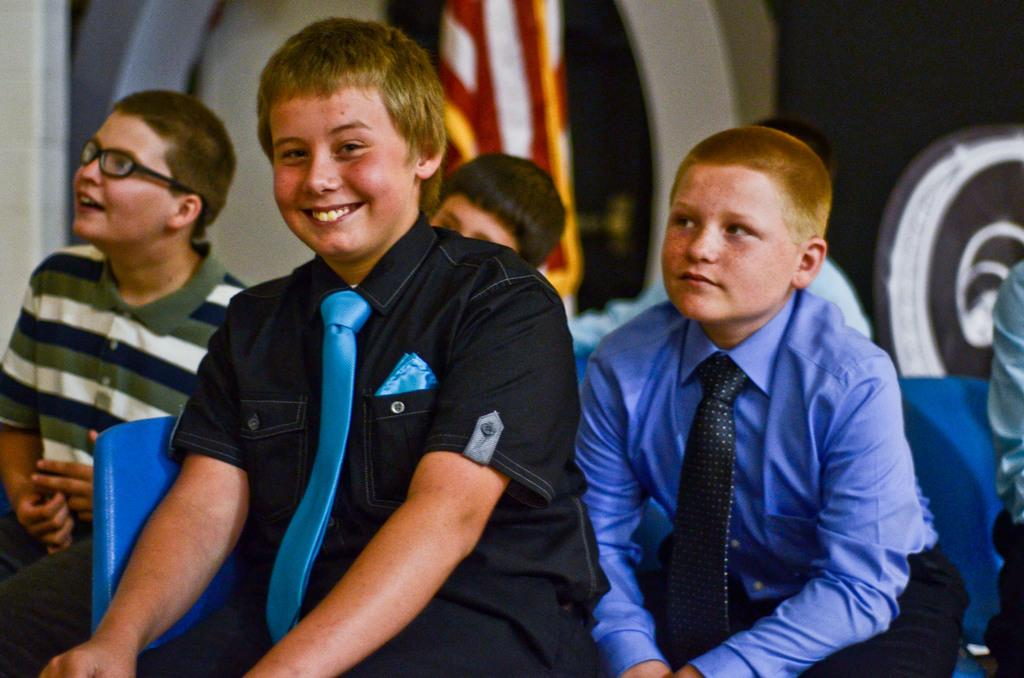How many boys are in the image? There are boys in the image. What are the boys doing in the image? The boys are sitting on chairs in the image. Can you describe the facial expression of one of the boys? There is a boy smiling in the image. What can be observed about the background of the image? The background of the image is blurred. What type of stamp can be seen on the boy's forehead in the image? There is no stamp visible on any of the boys' foreheads in the image. 